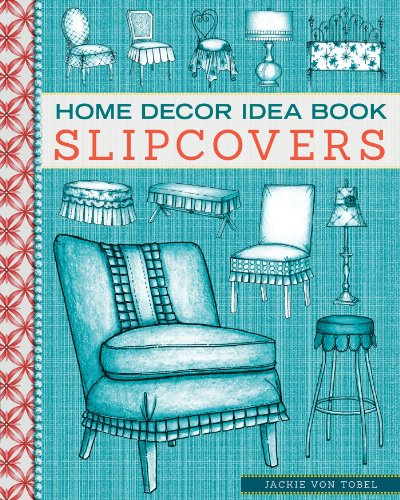Who is the author of this book? The author of the book shown in the image is Jackie Von Tobel, a renowned designer known for her detailed guides on home decorating. 